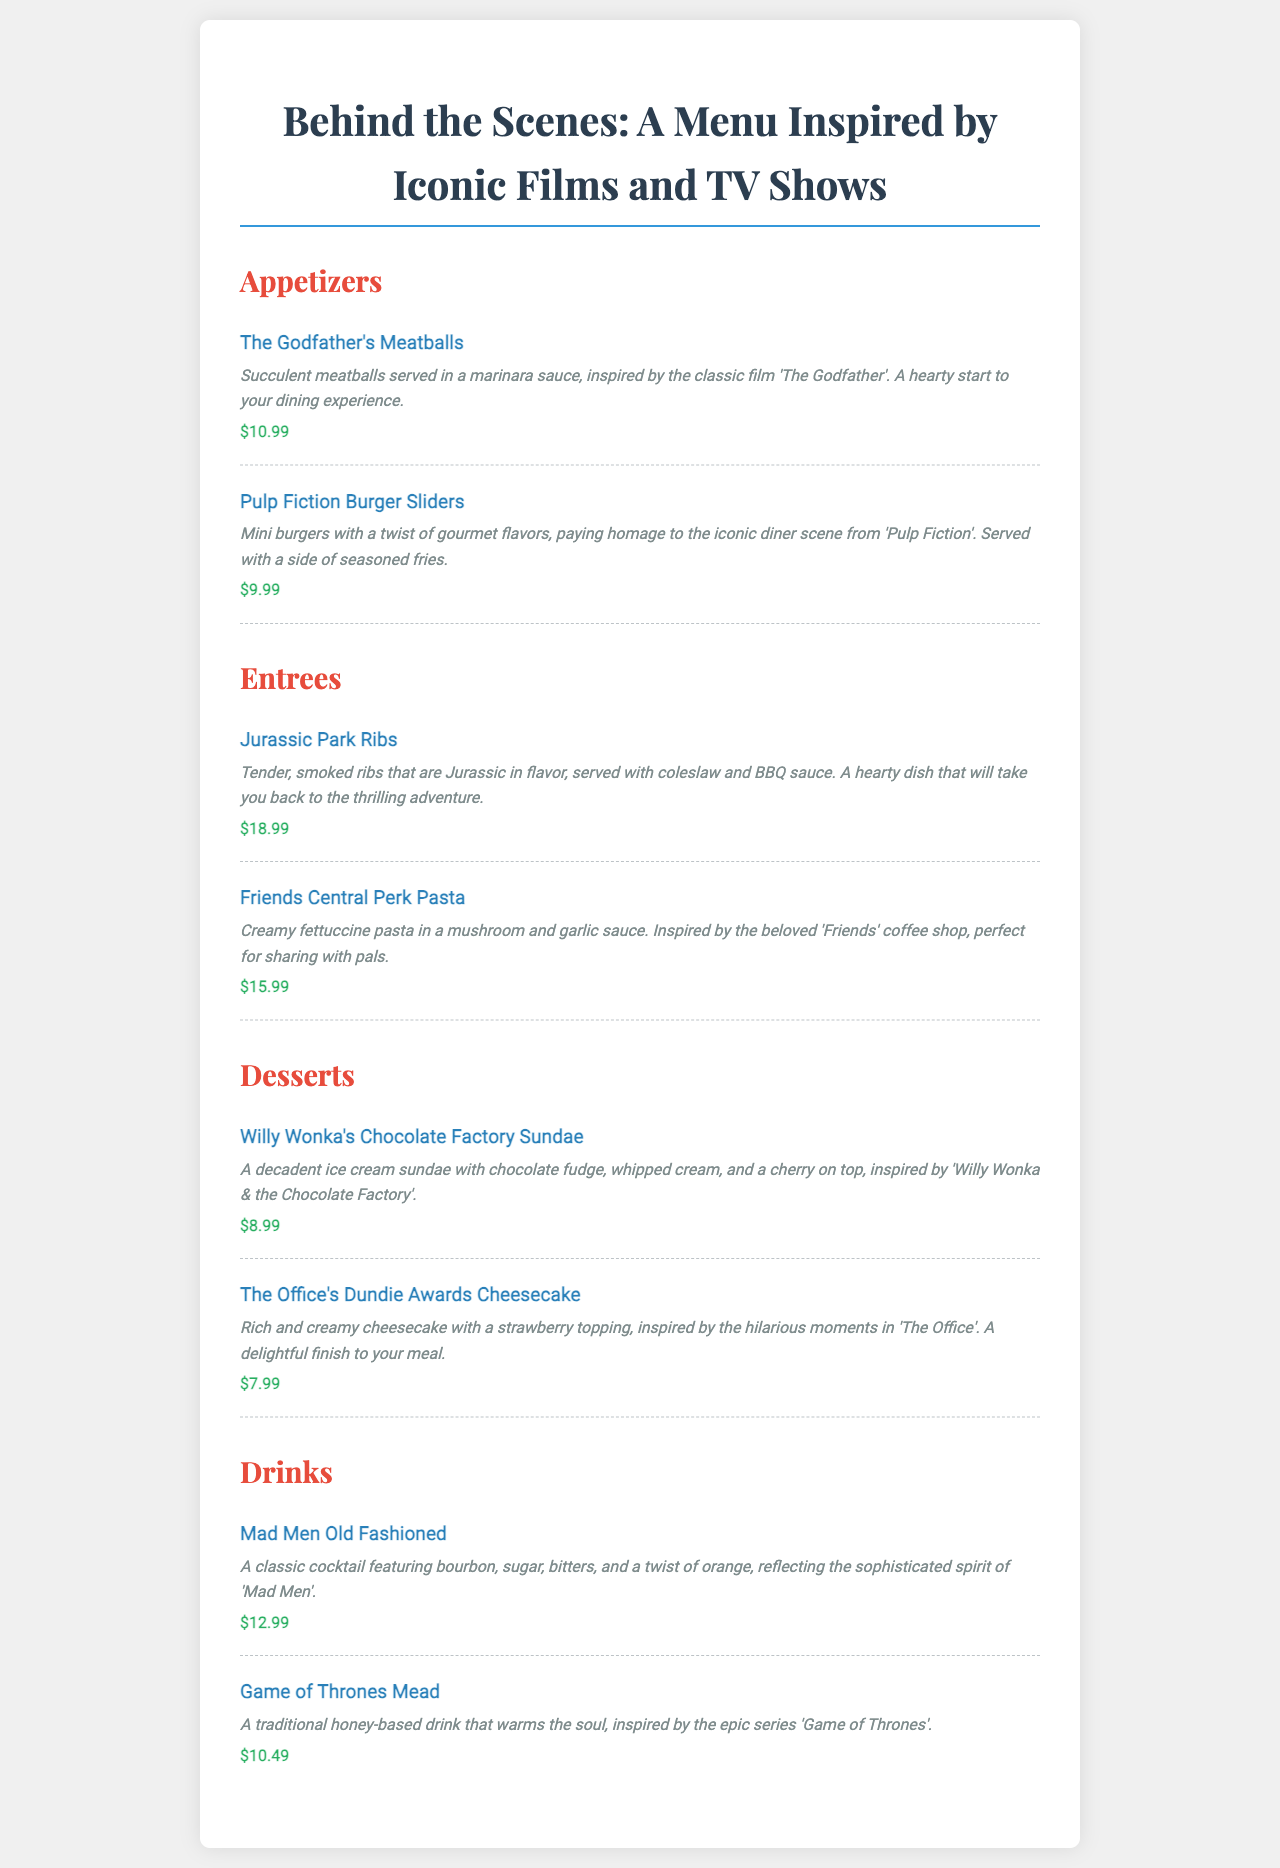What is the price of The Godfather's Meatballs? The price of The Godfather's Meatballs is specified in the menu, which is $10.99.
Answer: $10.99 What inspired the Friends Central Perk Pasta? The Friends Central Perk Pasta is inspired by the beloved coffee shop from the TV show 'Friends'.
Answer: Friends How much does the Game of Thrones Mead cost? The cost of the Game of Thrones Mead is listed in the menu, which is $10.49.
Answer: $10.49 What type of drink is the Mad Men Old Fashioned? The Mad Men Old Fashioned is a classic cocktail as mentioned in the drink description.
Answer: Cocktail Which dessert is inspired by 'Willy Wonka & the Chocolate Factory'? The dessert inspired by 'Willy Wonka & the Chocolate Factory' is named Willy Wonka's Chocolate Factory Sundae.
Answer: Willy Wonka's Chocolate Factory Sundae What is the theme of the appetizers section? The appetizers section features dishes inspired by iconic films, such as 'The Godfather' and 'Pulp Fiction'.
Answer: Iconic films How many appetizer items are listed in the menu? There are two appetizer items listed in the menu: The Godfather's Meatballs and Pulp Fiction Burger Sliders.
Answer: Two Which item has a price of $8.99? The item with a price of $8.99 is Willy Wonka's Chocolate Factory Sundae.
Answer: Willy Wonka's Chocolate Factory Sundae What ingredient is common in the drinks offered? The drinks offered, like Mad Men Old Fashioned and Game of Thrones Mead, commonly feature alcohol.
Answer: Alcohol 